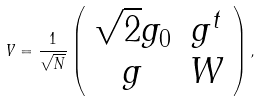<formula> <loc_0><loc_0><loc_500><loc_500>V = \frac { 1 } { \sqrt { N } } \left ( \begin{array} { c c } \sqrt { 2 } g _ { 0 } & g ^ { t } \\ g & W \end{array} \right ) ,</formula> 